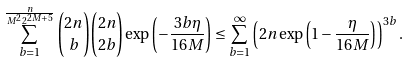<formula> <loc_0><loc_0><loc_500><loc_500>\sum _ { b = 1 } ^ { \frac { n } { M ^ { 2 } 2 ^ { 2 M + 5 } } } \binom { 2 n } { b } \binom { 2 n } { 2 b } \exp \left ( - \frac { 3 b \eta } { 1 6 M } \right ) & \leq \sum _ { b = 1 } ^ { \infty } \left ( 2 n \exp \left ( 1 - \frac { \eta } { 1 6 M } \right ) \right ) ^ { 3 b } .</formula> 